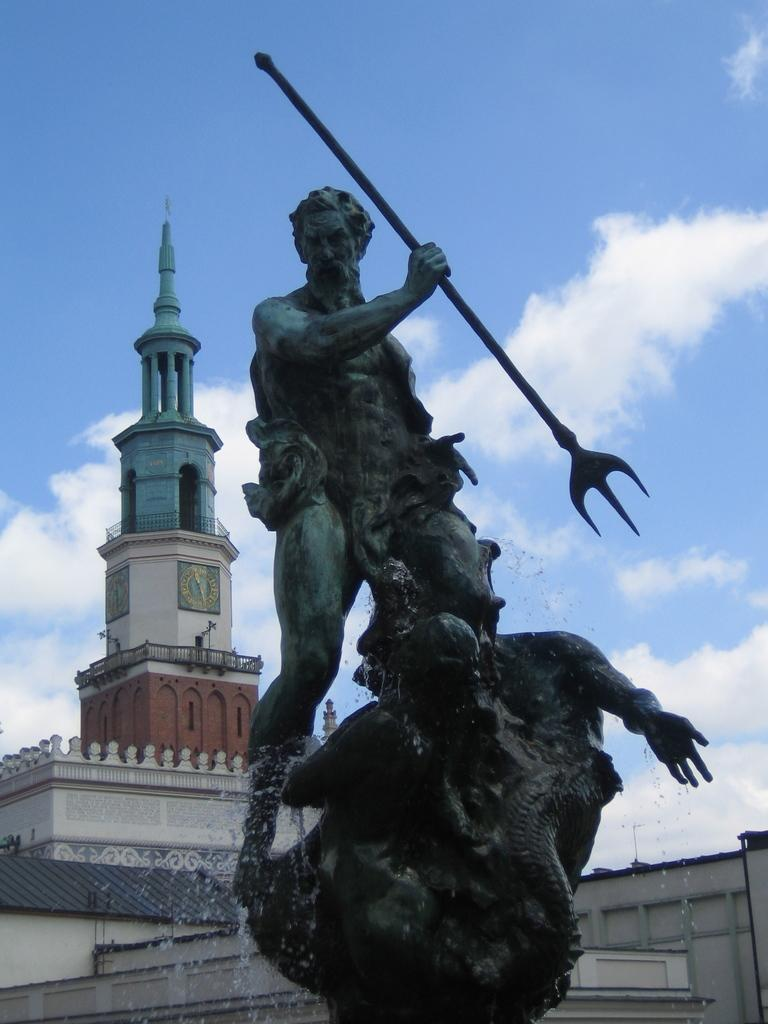What is the main subject of the image? There is a statue of a human in the image. What is the statue holding in its hand? The statue is holding a weapon in its hand. What type of structure can be seen in the image? There is a building in the image. What is visible in the sky in the image? There are clouds in the sky. What message is displayed on the sign near the statue in the image? There is no sign present in the image; it only features a statue holding a weapon and a building in the background. Can you tell me how many firemen are visible in the image? There are no firemen present in the image. 